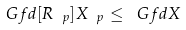Convert formula to latex. <formula><loc_0><loc_0><loc_500><loc_500>\ G f d [ R _ { \ p } ] { X _ { \ p } } \leq \ G f d { X }</formula> 